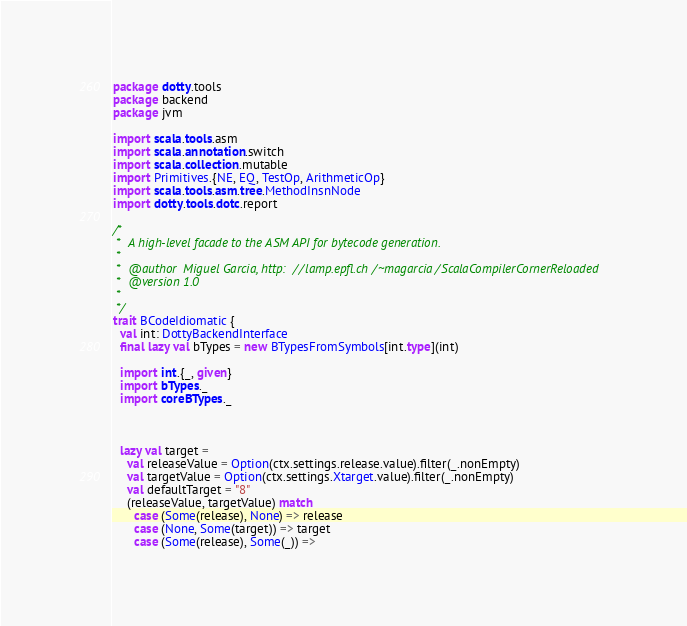Convert code to text. <code><loc_0><loc_0><loc_500><loc_500><_Scala_>package dotty.tools
package backend
package jvm

import scala.tools.asm
import scala.annotation.switch
import scala.collection.mutable
import Primitives.{NE, EQ, TestOp, ArithmeticOp}
import scala.tools.asm.tree.MethodInsnNode
import dotty.tools.dotc.report

/*
 *  A high-level facade to the ASM API for bytecode generation.
 *
 *  @author  Miguel Garcia, http://lamp.epfl.ch/~magarcia/ScalaCompilerCornerReloaded
 *  @version 1.0
 *
 */
trait BCodeIdiomatic {
  val int: DottyBackendInterface
  final lazy val bTypes = new BTypesFromSymbols[int.type](int)

  import int.{_, given}
  import bTypes._
  import coreBTypes._



  lazy val target =
    val releaseValue = Option(ctx.settings.release.value).filter(_.nonEmpty)
    val targetValue = Option(ctx.settings.Xtarget.value).filter(_.nonEmpty)
    val defaultTarget = "8"
    (releaseValue, targetValue) match
      case (Some(release), None) => release
      case (None, Some(target)) => target
      case (Some(release), Some(_)) =></code> 